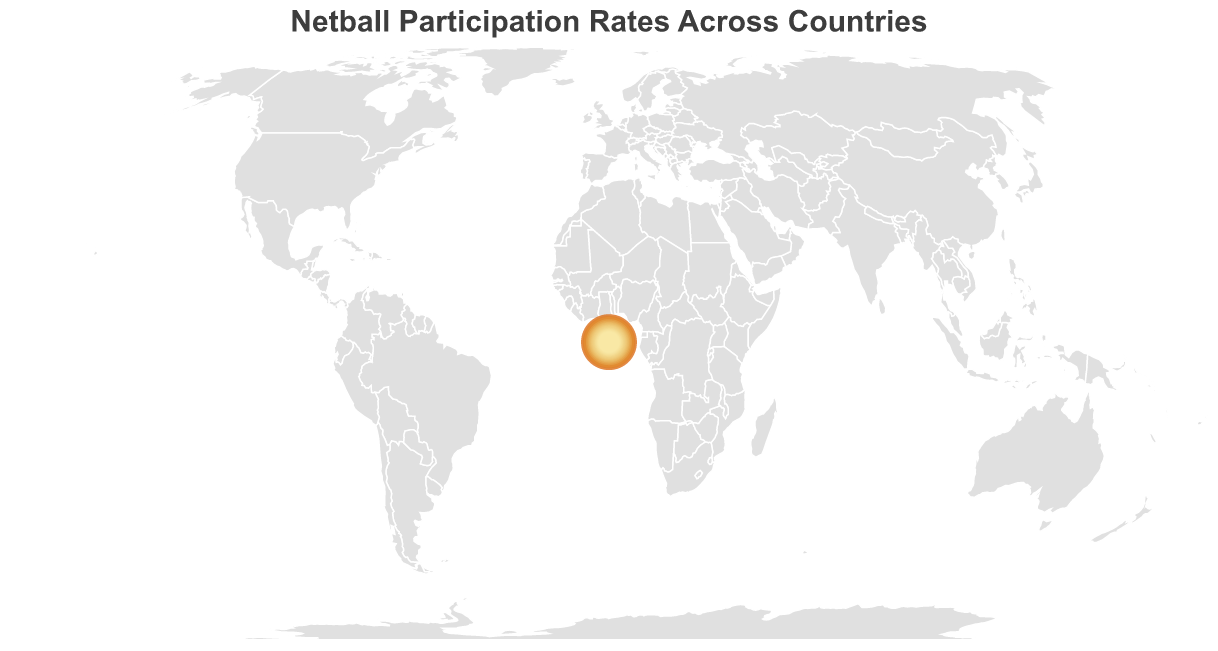What is the title of the figure? The title is usually displayed at the top of the figure and summarizes the content. The title here is "Netball Participation Rates Across Countries" as indicated in the provided code.
Answer: Netball Participation Rates Across Countries Which country has the highest netball participation rate? By looking at the data points, the country with the highest participation rate is the one with the largest circle size. According to the data, Fiji has the highest participation rate at 18.5%.
Answer: Fiji What color represents a high participation rate in the figure? The color of higher participation rates ranges from light yellow to dark orange. The highest rates are represented by dark orange.
Answer: Dark orange How many countries have a participation rate greater than 10%? By examining the data, we see that Fiji, New Zealand, Australia, Jamaica, and England have participation rates greater than 10%. Counting these countries gives us five such countries.
Answer: 5 Which countries have participation rates between 5% and 10%? From the data, countries with participation rates between 5% and 10% are South Africa, Malawi, Uganda, Trinidad and Tobago, Samoa, Barbados, Scotland, and Wales.
Answer: South Africa, Malawi, Uganda, Trinidad and Tobago, Samoa, Barbados, Scotland, Wales What is the difference in participation rates between Fiji and New Zealand? Subtract the participation rate of New Zealand from that of Fiji: 18.5 - 16.2 = 2.3.
Answer: 2.3 Order the following countries by their participation rates from highest to lowest: New Zealand, Jamaica, Zimbabwe. From the data, the participation rates are: New Zealand (16.2), Jamaica (12.3), Zimbabwe (3.3). Arranging these from highest to lowest: New Zealand, Jamaica, Zimbabwe.
Answer: New Zealand, Jamaica, Zimbabwe What are the smallest and largest participation rates displayed in the figure? According to the data points, the smallest participation rate is Zambia with 2.1% and the largest is Fiji with 18.5%.
Answer: Zambia, Fiji Which countries are depicted with the smallest circle size on the map? The smallest circle size indicates the lowest participation rate, which is Zambia with 2.1%.
Answer: Zambia Is Australia's participation rate higher or lower than Uganda's? From the data, Australia's participation rate (14.8%) is higher than Uganda's (7.9%).
Answer: Higher 